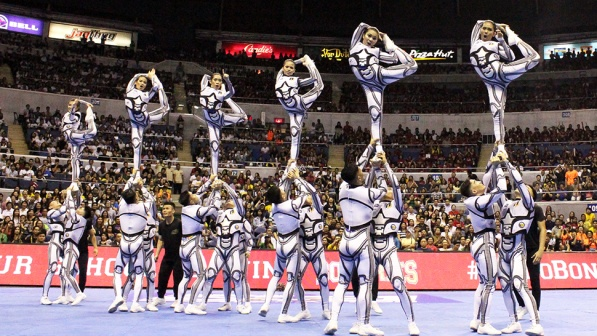What do you think the crowd is feeling as they watch the performance? The crowd is likely feeling a mixture of excitement, awe, and anticipation. The cheerleaders' high-flying moves and precise stunts are visually stunning, capturing everyone's attention. The spectators might be on the edge of their seats, cheering enthusiastically and taking photos to capture the moment. Their faces may be lit with smiles, wide eyes, and expressions of amazement, reflecting the thrilling atmosphere of the event. 